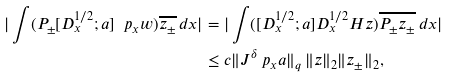<formula> <loc_0><loc_0><loc_500><loc_500>| \int ( P _ { \pm } [ D _ { x } ^ { 1 / 2 } ; a ] \ p _ { x } w ) \overline { z _ { \pm } } \, d x | & = | \int ( [ D _ { x } ^ { 1 / 2 } ; a ] D _ { x } ^ { 1 / 2 } H z ) \overline { P _ { \pm } z _ { \pm } } \, d x | \\ & \leq c \| J ^ { \delta } \ p _ { x } a \| _ { q } \, \| z \| _ { 2 } \| z _ { \pm } \| _ { 2 } ,</formula> 